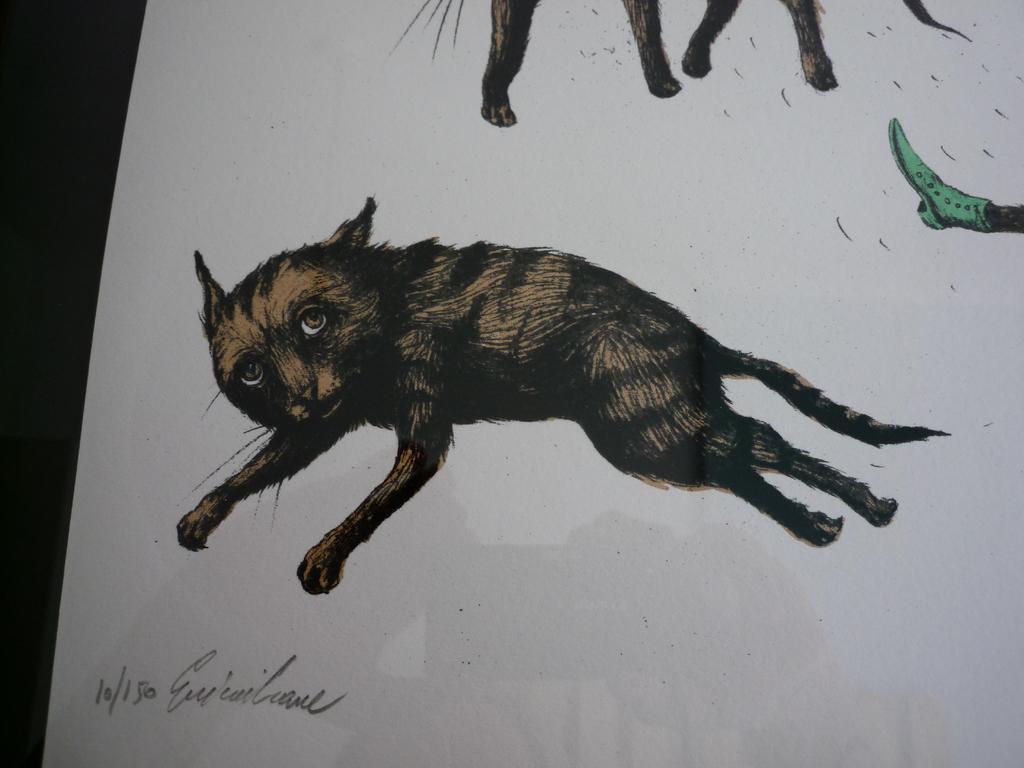Can you describe this image briefly? In this picture we can see a paper and in this paper we can see a person leg with a shoe, animals and some text. 